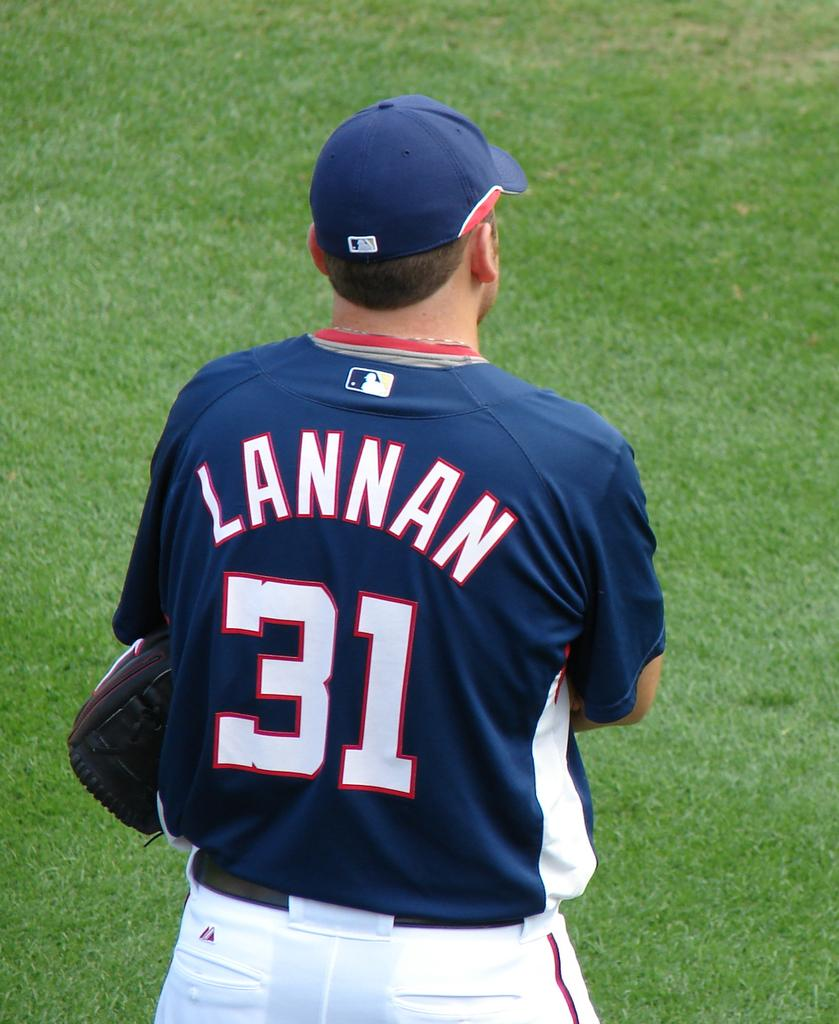<image>
Provide a brief description of the given image. A baseball player with the last name Lannan wearing a blue jersey with the number 31 on it. 